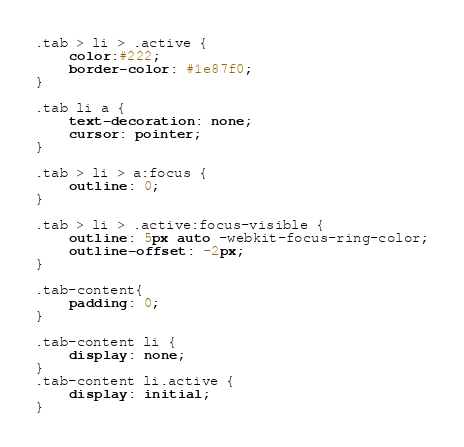Convert code to text. <code><loc_0><loc_0><loc_500><loc_500><_CSS_>.tab > li > .active {
    color:#222;
    border-color: #1e87f0;
}

.tab li a {
    text-decoration: none;
    cursor: pointer;
}

.tab > li > a:focus {
    outline: 0;
}

.tab > li > .active:focus-visible {
    outline: 5px auto -webkit-focus-ring-color;
    outline-offset: -2px;
}

.tab-content{
    padding: 0;
}

.tab-content li {
    display: none;
}
.tab-content li.active {
    display: initial;
}
</code> 